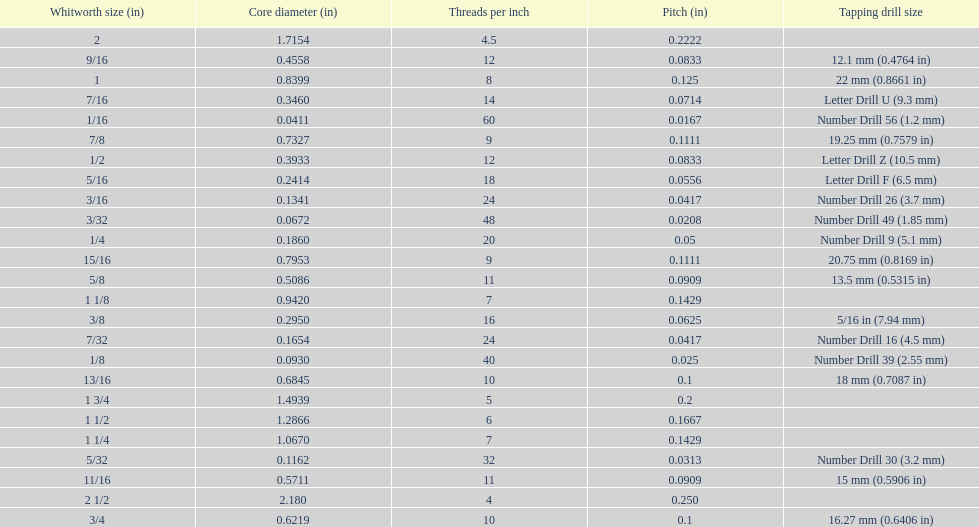What is the top amount of threads per inch? 60. 